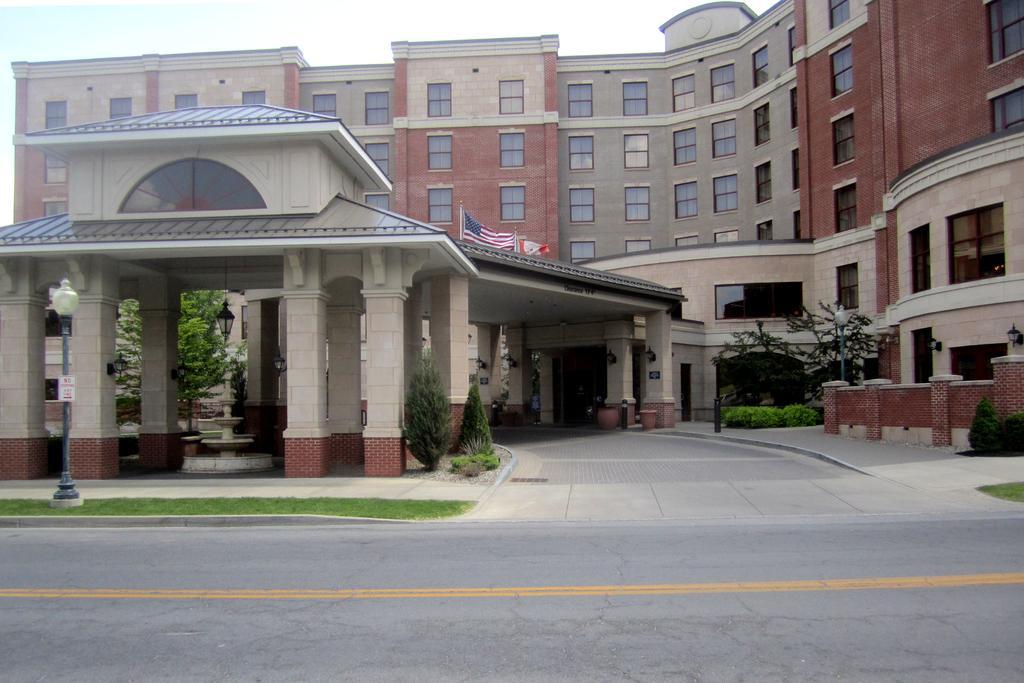Can you describe this image briefly? In this picture we can see a road, beside this road we can see electric poles with lights, grass, plants, trees, here we can see a building, flags, name board, metal poles and some objects and we can see sky in the background. 